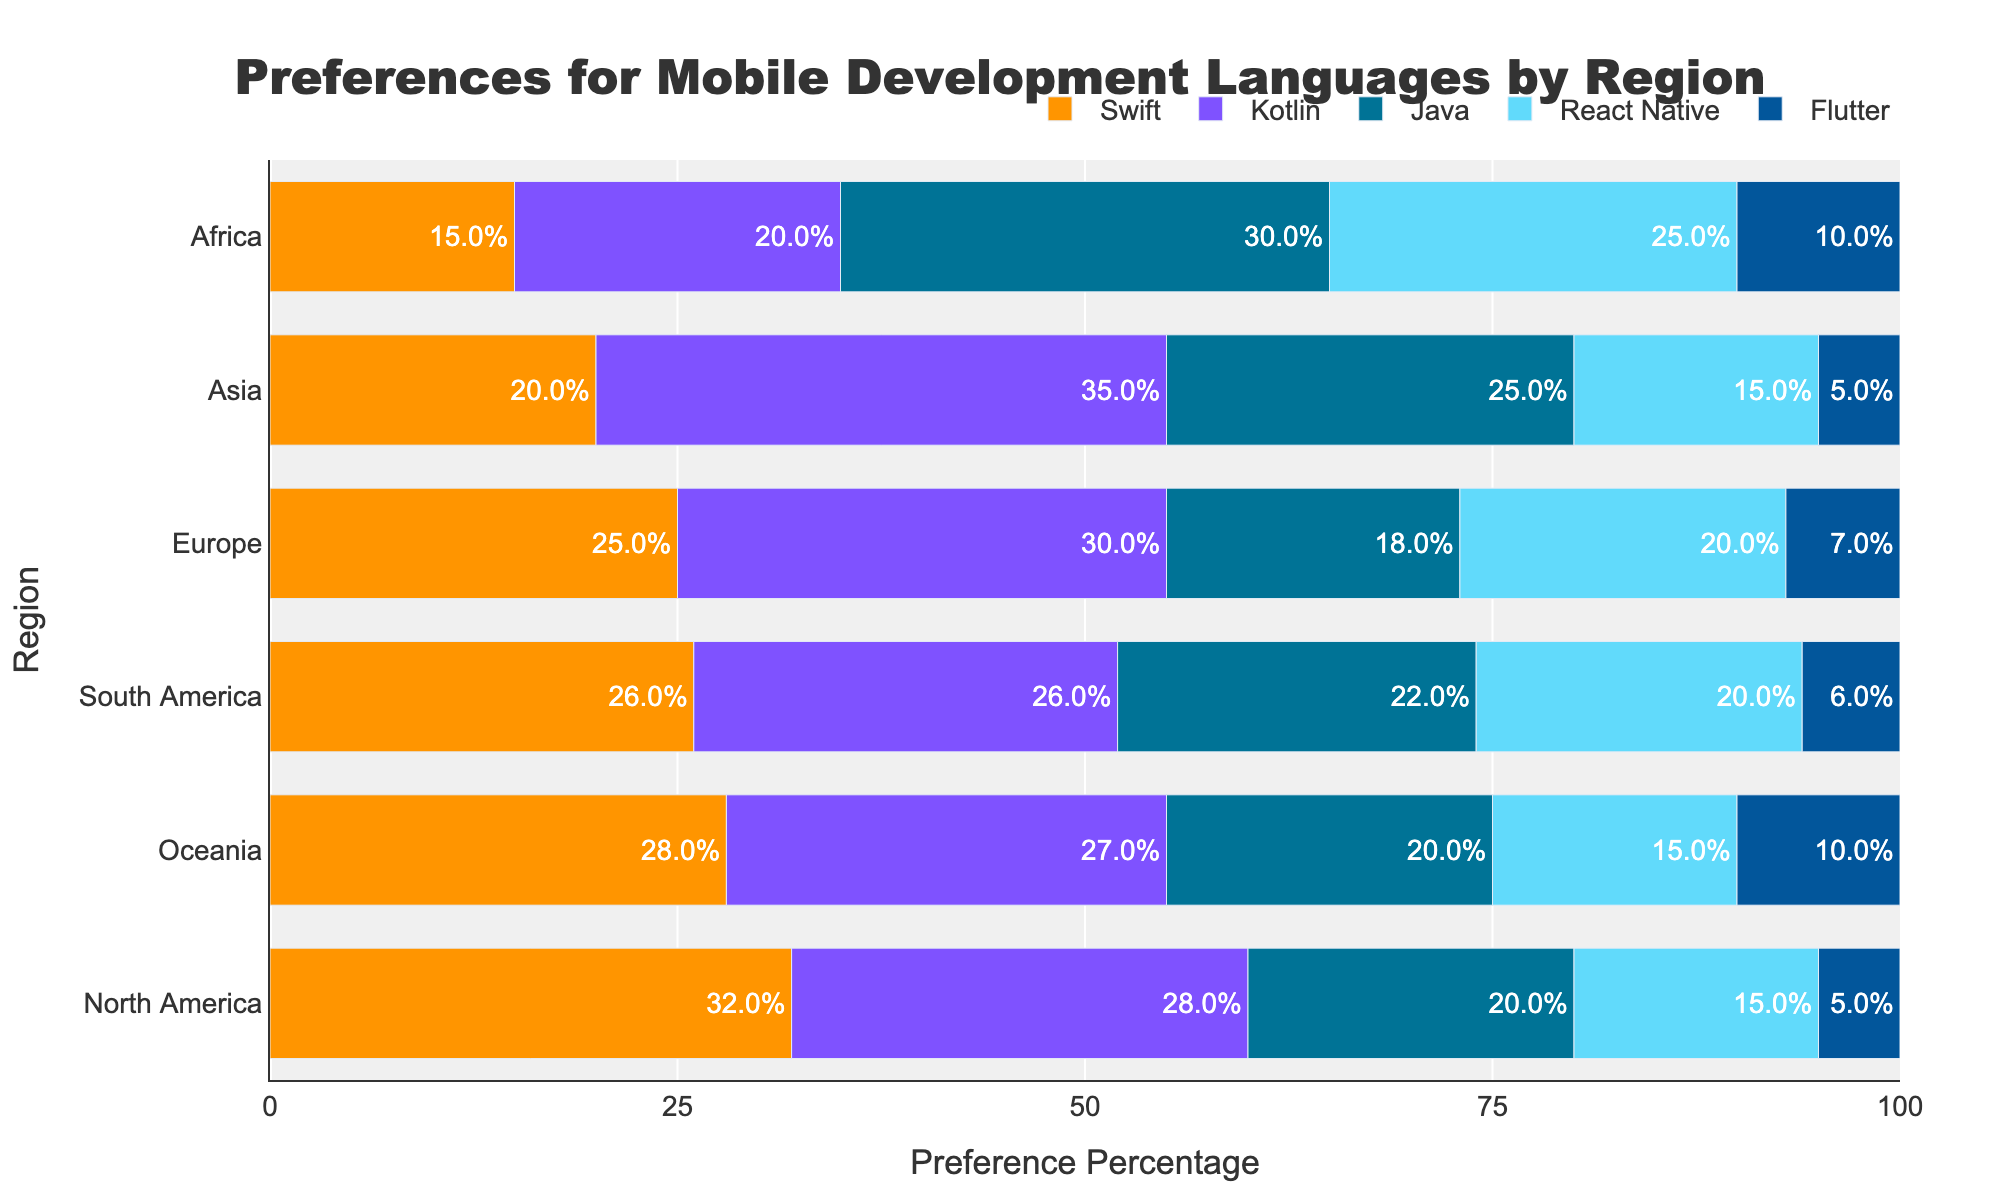What is the most preferred mobile development language in Asia? The preference percentage for each language in Asia is Swift 20%, Kotlin 35%, Java 25%, React Native 15%, and Flutter 5%. Kotlin has the highest preference percentage.
Answer: Kotlin Which region has the highest preference for Java? Comparing the preference percentages for Java across regions: North America 20%, Europe 18%, Asia 25%, South America 22%, and Africa 30%. Africa has the highest preference percentage for Java.
Answer: Africa What's the combined preference percentage for Swift and Kotlin in North America? The preference percentage for Swift in North America is 32% and for Kotlin is 28%. Adding these values gives 32 + 28 = 60%.
Answer: 60% Which language has the lowest preference in Europe? The preference percentages in Europe for each language are Swift 25%, Kotlin 30%, Java 18%, React Native 20%, and Flutter 7%. Flutter has the lowest preference percentage.
Answer: Flutter Is React Native more preferred in Africa or North America? The preference percentage for React Native in Africa is 25%, and in North America, it is 15%. 25% > 15%, so React Native is more preferred in Africa.
Answer: Africa How does the preference for Flutter in South America compare to that in Oceania? The preference percentage for Flutter in South America is 6%, and in Oceania, it is 10%. 10% > 6%, so Flutter is more preferred in Oceania.
Answer: Oceania Which region shows the most balanced preference between Swift and Kotlin? The regions and their percentages for Swift and Kotlin: North America (Swift 32%, Kotlin 28%), Europe (Swift 25%, Kotlin 30%), Asia (Swift 20%, Kotlin 35%), South America (Swift 26%, Kotlin 26%), and Africa (Swift 15%, Kotlin 20%). South America has the most balanced preference with equal percentages (26% for both).
Answer: South America 